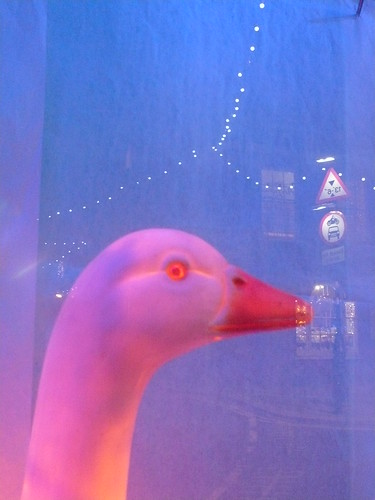What material does the toy appear to be made from, and what might be the reason for choosing this material? The toy appears to be constructed from a type of plastic, evident from its glossy and smooth finish. Plastic is a popular choice for toys as it is durable, easy to mold into various shapes, and cost-effective, allowing for detailed and lasting designs. 